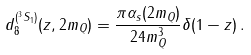Convert formula to latex. <formula><loc_0><loc_0><loc_500><loc_500>d _ { 8 } ^ { ( ^ { 3 } S _ { 1 } ) } ( z , 2 m _ { Q } ) = \frac { \pi \alpha _ { s } ( 2 m _ { Q } ) } { 2 4 m _ { Q } ^ { 3 } } \delta ( 1 - z ) \, .</formula> 